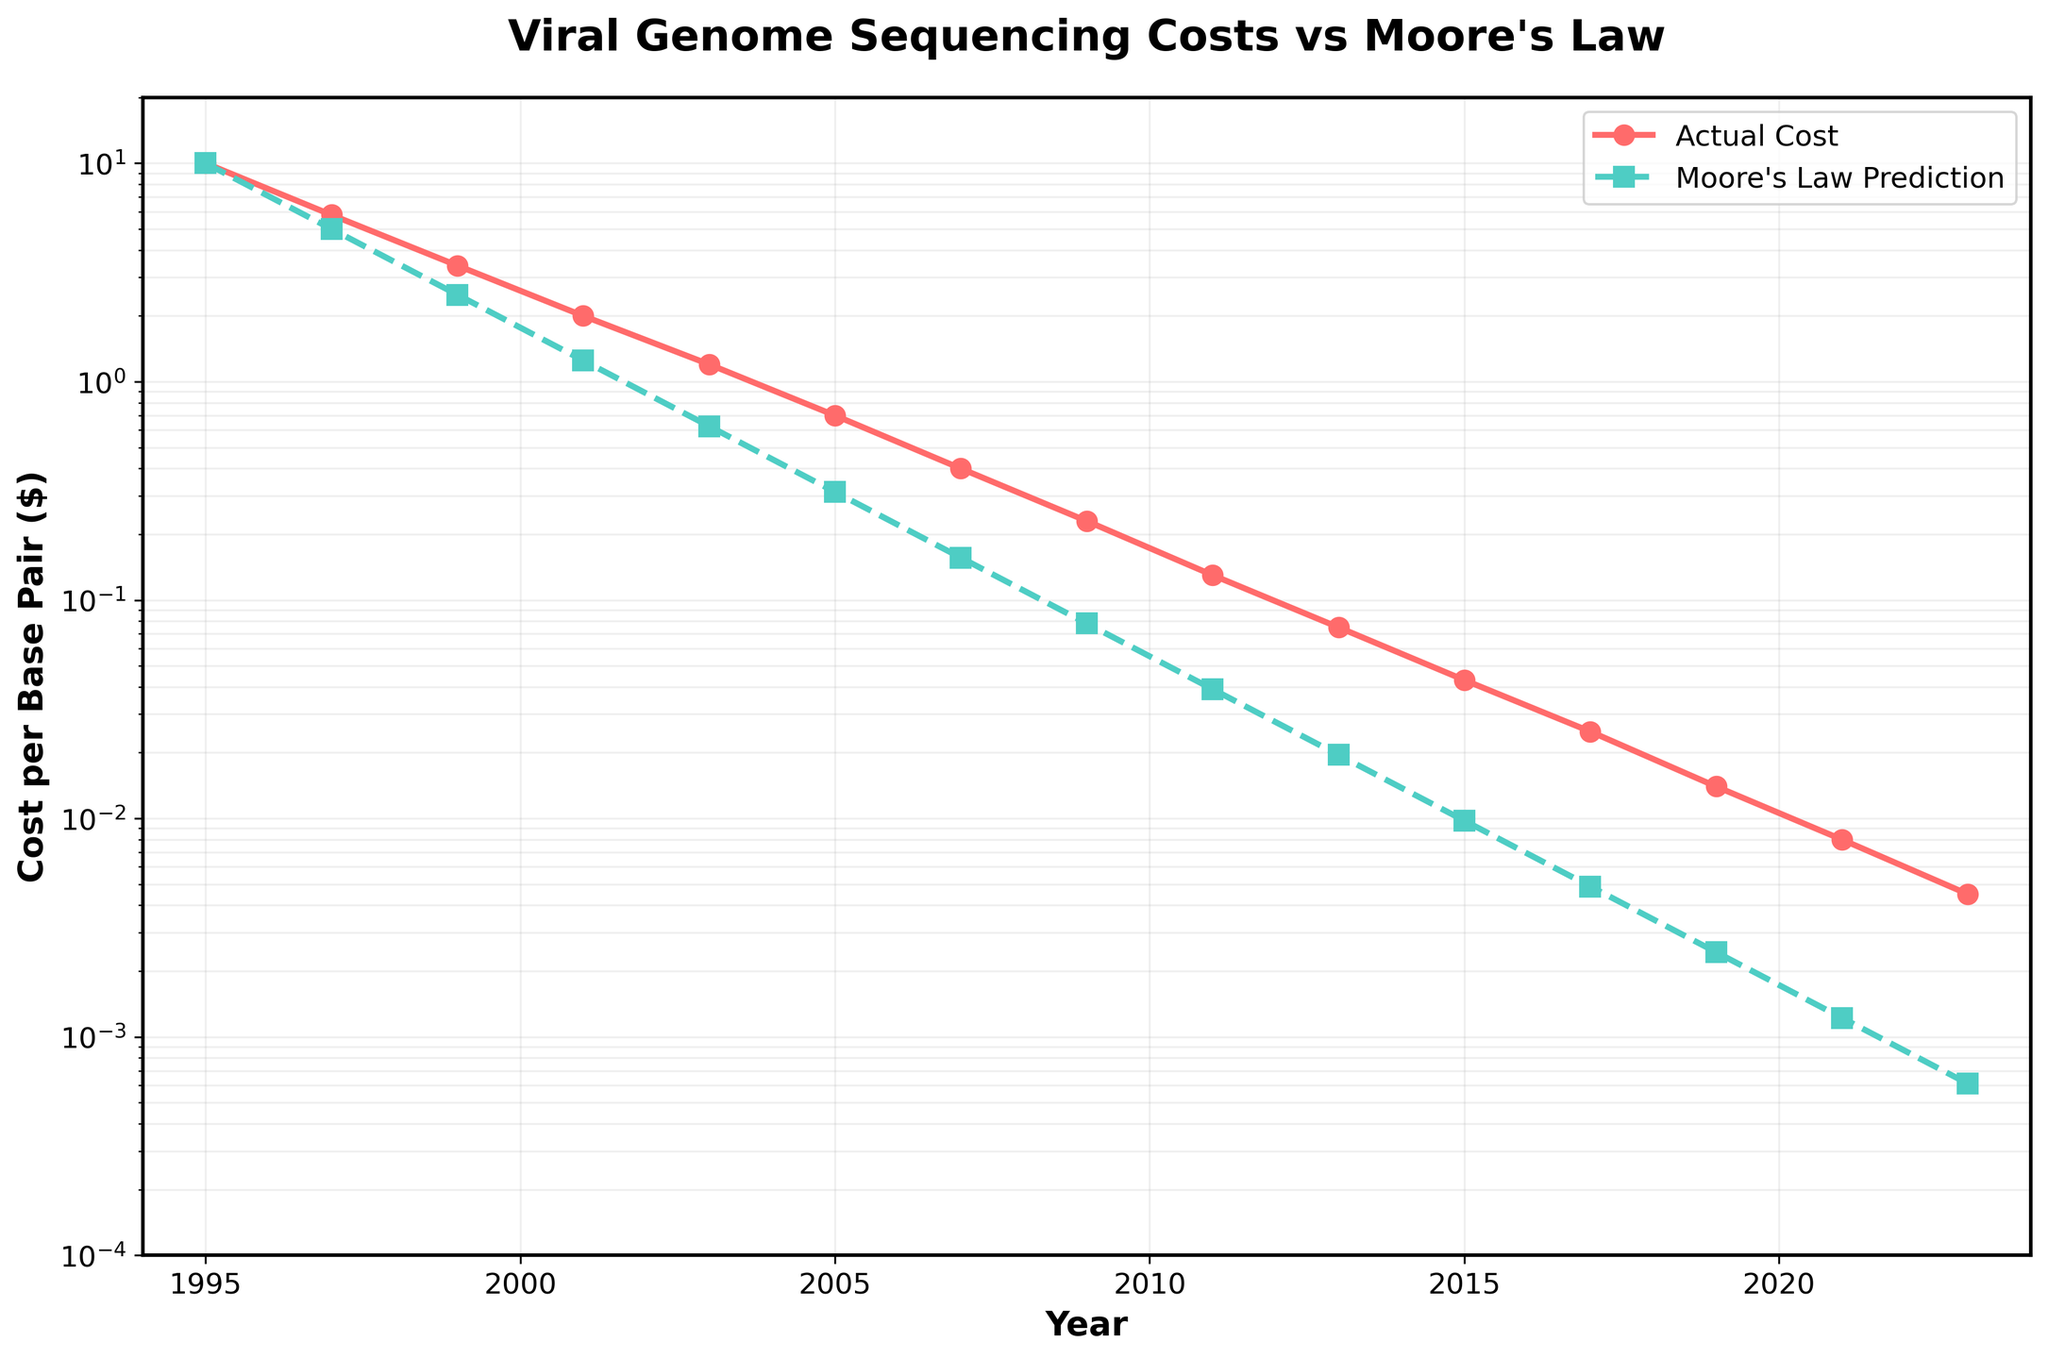What's the trend of the actual cost per base pair from 1995 to 2023? The actual cost per base pair has been decreasing steadily over the years. By observing the line depicting the actual cost, we can see a downward trend from $10 per base pair in 1995 to $0.0045 in 2023.
Answer: Decreasing How does the actual cost in 2023 compare with Moore's Law prediction in the same year? In 2023, the actual cost per base pair is $0.0045, which is higher than Moore's Law prediction of $0.000610352. The actual cost is still significantly above the predicted value by Moore's Law.
Answer: Higher In which year did the actual cost per base pair first fall below $1? Looking at the graph, the actual cost per base pair first fell below $1 between 2001 and 2003. The exact year can be inferred as 2003 when the cost is $1.2, which is closer but still above $1. So it must have been in 2003.
Answer: 2003 What's the difference between the actual cost and Moore's Law prediction in the year 2011? For 2011, the actual cost per base pair is $0.13 and Moore's Law prediction is $0.0390625. The difference is calculated as $0.13 - $0.0390625.
Answer: $0.0909375 How does the actual cost reduction from 1995 to 2023 compare with Moore's Law prediction over the same period? In 1995, the actual cost per base pair was $10, and in 2023, it was $0.0045. The reduction in cost is $10 - $0.0045 = $9.9955. For Moore's Law prediction, the cost in 1995 was $10 and in 2023, it was $0.000610352. The reduction is $10 - $0.000610352 = $9.999389648. Comparing these reductions shows that the actual cost did not reduce as much as the prediction.
Answer: Less In which years does the actual cost curve deviate the most from the Moore's Law prediction? The greatest deviation occurs when there is a noticeable visual gap between the lines. By visually inspecting the chart, it appears that post-2005, particularly in the years around 2007 to 2019, the deviations are most significant. This can be observed from the spacing between the two lines.
Answer: 2007-2019 What’s the average actual cost per base pair between 2009 and 2015? The actual costs in 2009, 2011, 2013, and 2015 are $0.23, $0.13, $0.075, and $0.043, respectively. Summing these values gives $0.23 + $0.13 + $0.075 + $0.043 = $0.478. There are 4 years, so the average is $0.478 / 4.
Answer: $0.1195 Compare the slope of the actual cost and Moore's Law prediction curves from 1995 to 2023. Both curves show a downward trend; however, the actual cost per base pair decreases at a lesser rate compared to Moore's Law prediction. This is evident from the steepness of the lines. Moore's Law prediction significantly drops steeper, thus indicating a higher rate of decrease as compared to the actual cost which declines more gradually.
Answer: Steeper for Moore's Law What year had an actual cost close to Moore's Law prediction? By visually inspecting the chart, in the initial years, the values are closer. Around 1999 and 2001, the actual cost and Moore's Law prediction lines are nearly overlapping or very close, indicating the actual cost was quite close to the prediction.
Answer: 1999 and 2001 How many years did the actual cost drop by more than half between consecutive data points? Visually inspecting the graph, the significant drops in actual costs by more than half occurred between specific years: 1995 to 1997, 1997 to 1999, and 2001 to 2003, 2003 to 2005, and 2005 to 2007. We need to check multiple steps to identify the exact years, leading to four such intervals.
Answer: 4 years 